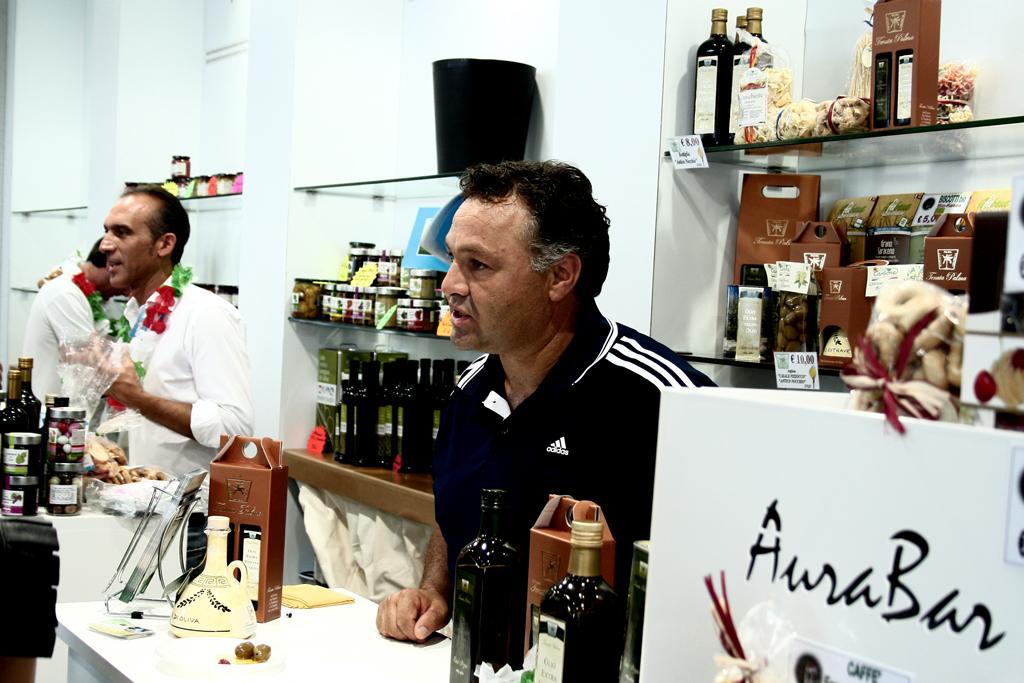What brand is his shirt?
Provide a short and direct response. Adidas. 